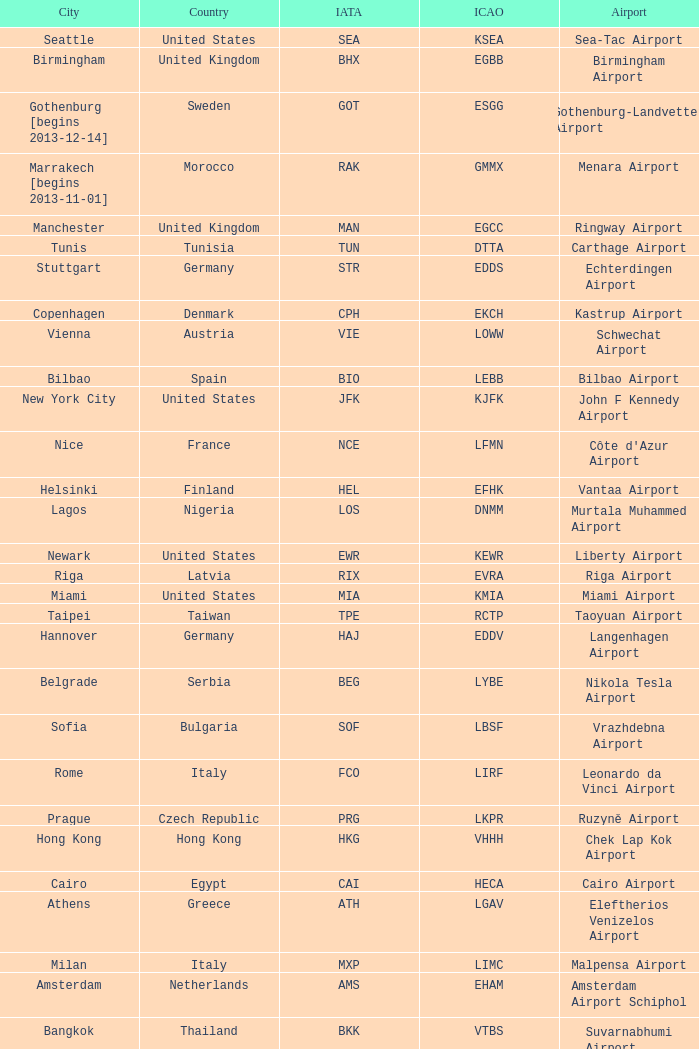What city is fuhlsbüttel airport in? Hamburg. 